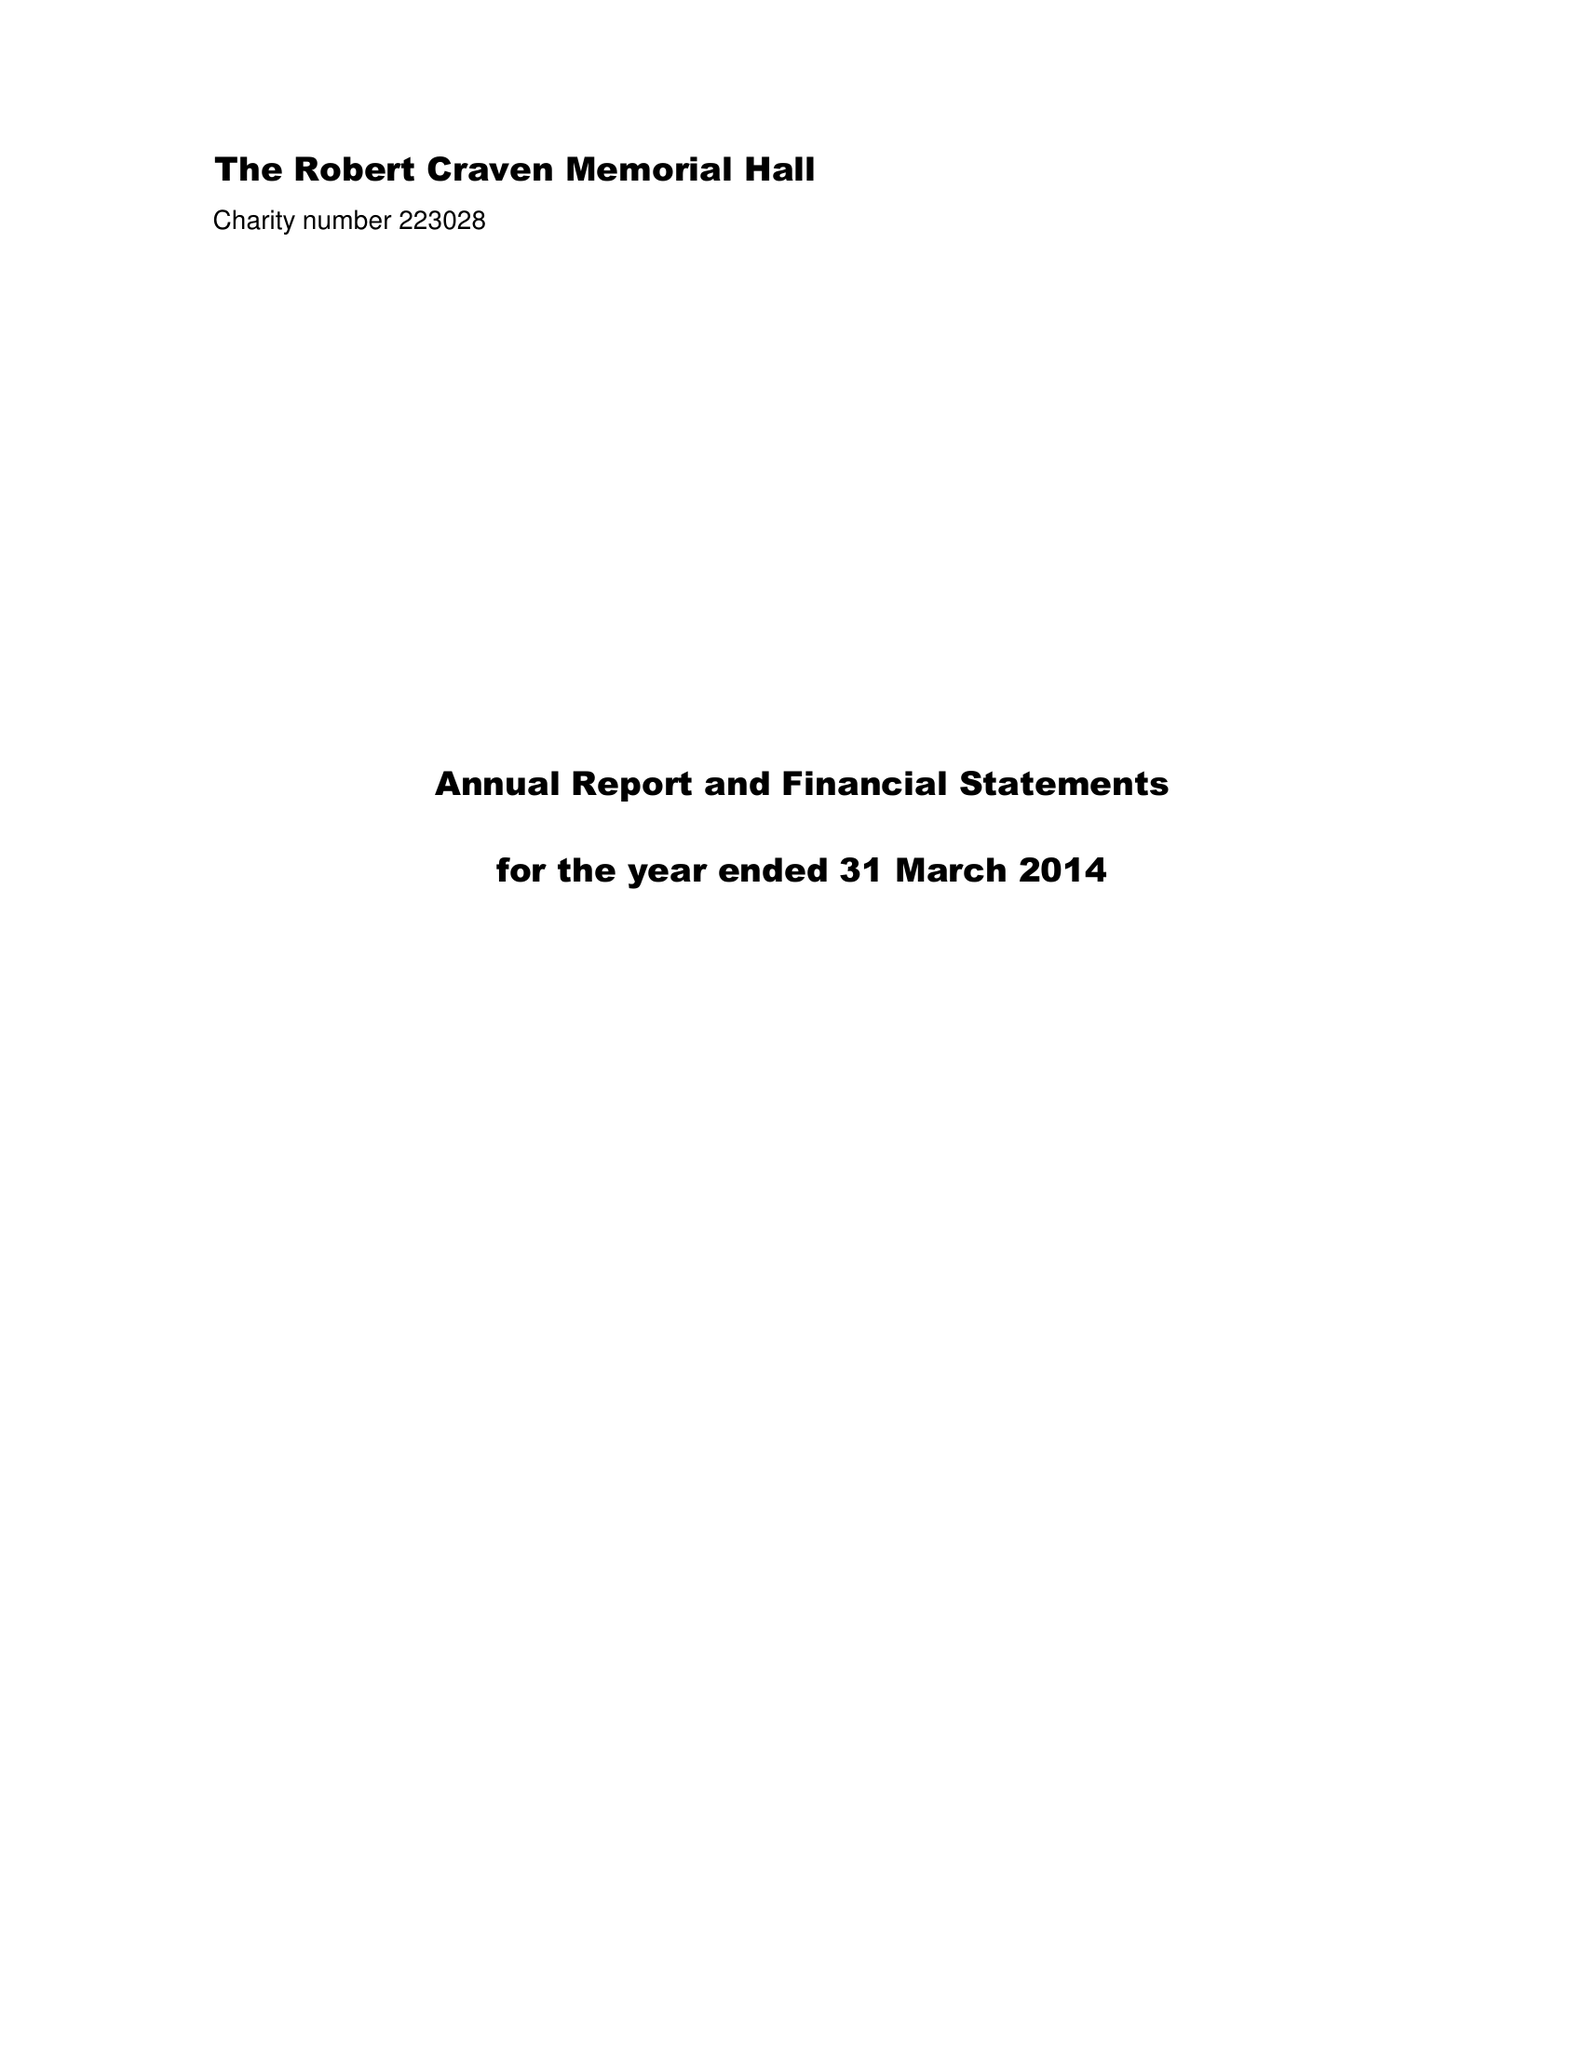What is the value for the income_annually_in_british_pounds?
Answer the question using a single word or phrase. 39548.00 